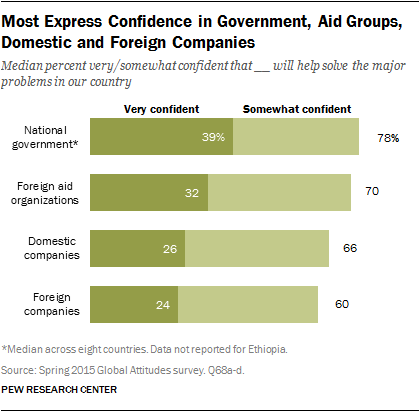Point out several critical features in this image. According to the survey, a significant percentage of people, or 39%, are very confident that the national government will help solve the major problems facing our country. The organization with the largest gap between very confident and somewhat confident responses is domestic companies. 